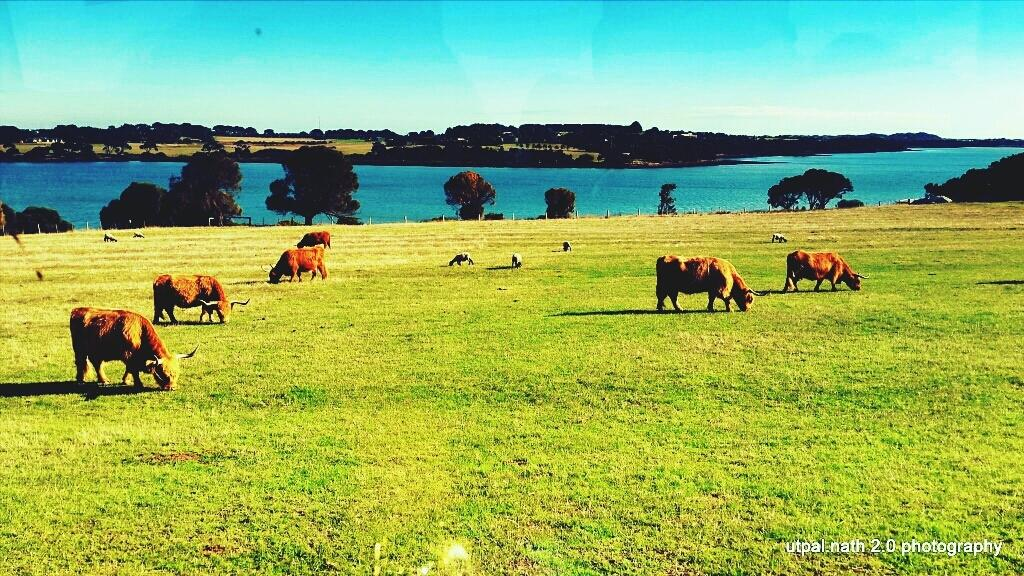What type of animals are in the image? There are bulls in the image. Are there any other animals besides the bulls? Yes, there are other animals in the image. What is the ground surface like where the animals are standing? The animals are standing on the grass. What can be seen in the background of the image? There are trees, poles, water, buildings, and the sky visible in the background of the image. Can you tell me how much milk the bulls are producing in the image? There is no indication of milk production in the image; it only shows bulls and other animals standing on the grass. What type of wilderness can be seen in the background of the image? The image does not depict a wilderness setting; it shows a background with trees, poles, water, buildings, and the sky. 